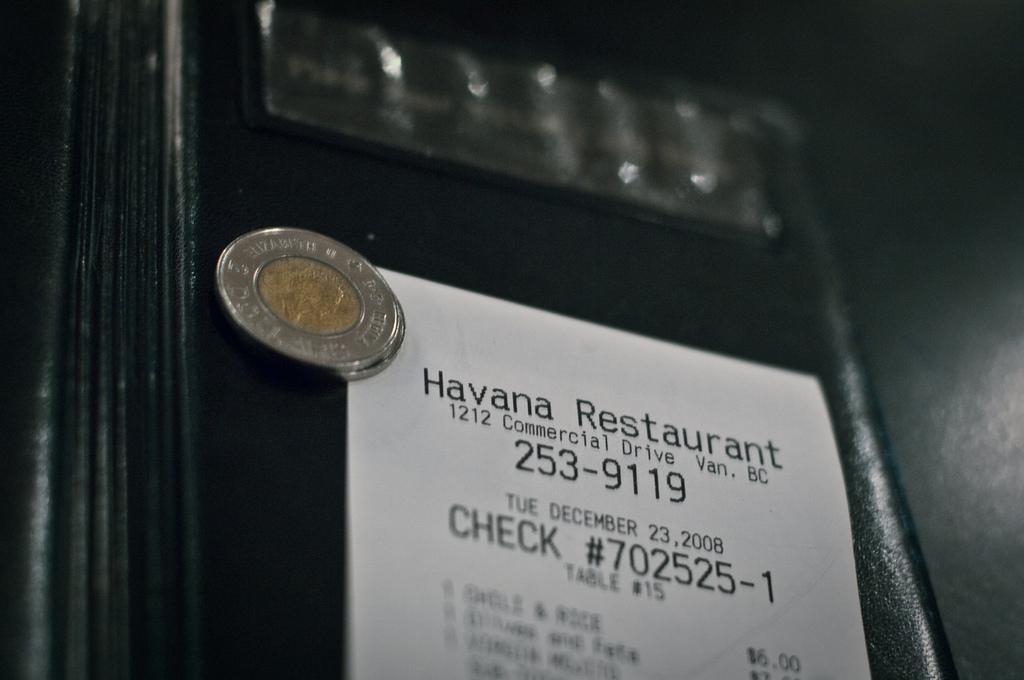What restaurant is that?
Give a very brief answer. Havana. What is the address on the receipt?
Offer a very short reply. 1212 commercial drive van. bc. 